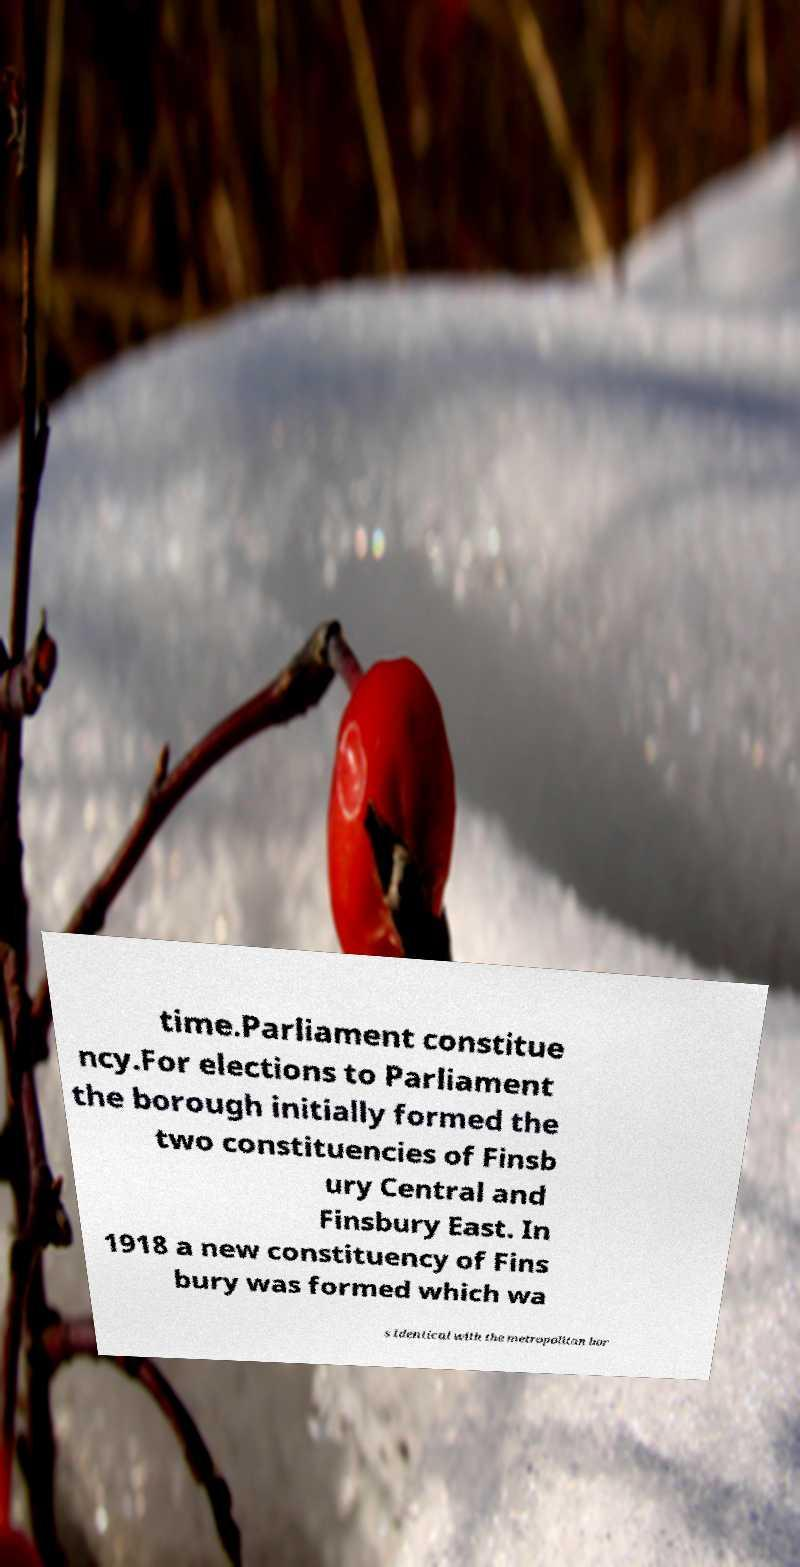Please read and relay the text visible in this image. What does it say? time.Parliament constitue ncy.For elections to Parliament the borough initially formed the two constituencies of Finsb ury Central and Finsbury East. In 1918 a new constituency of Fins bury was formed which wa s identical with the metropolitan bor 